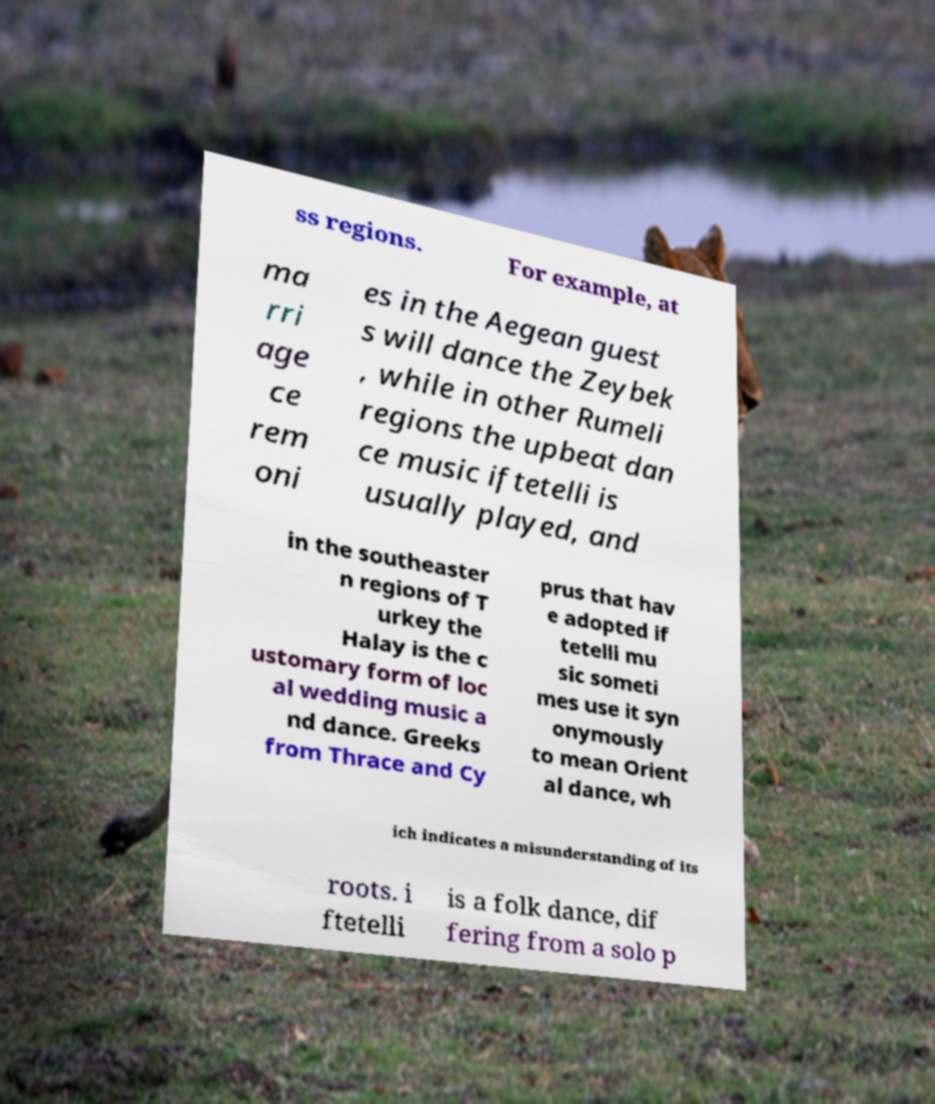Could you assist in decoding the text presented in this image and type it out clearly? ss regions. For example, at ma rri age ce rem oni es in the Aegean guest s will dance the Zeybek , while in other Rumeli regions the upbeat dan ce music iftetelli is usually played, and in the southeaster n regions of T urkey the Halay is the c ustomary form of loc al wedding music a nd dance. Greeks from Thrace and Cy prus that hav e adopted if tetelli mu sic someti mes use it syn onymously to mean Orient al dance, wh ich indicates a misunderstanding of its roots. i ftetelli is a folk dance, dif fering from a solo p 